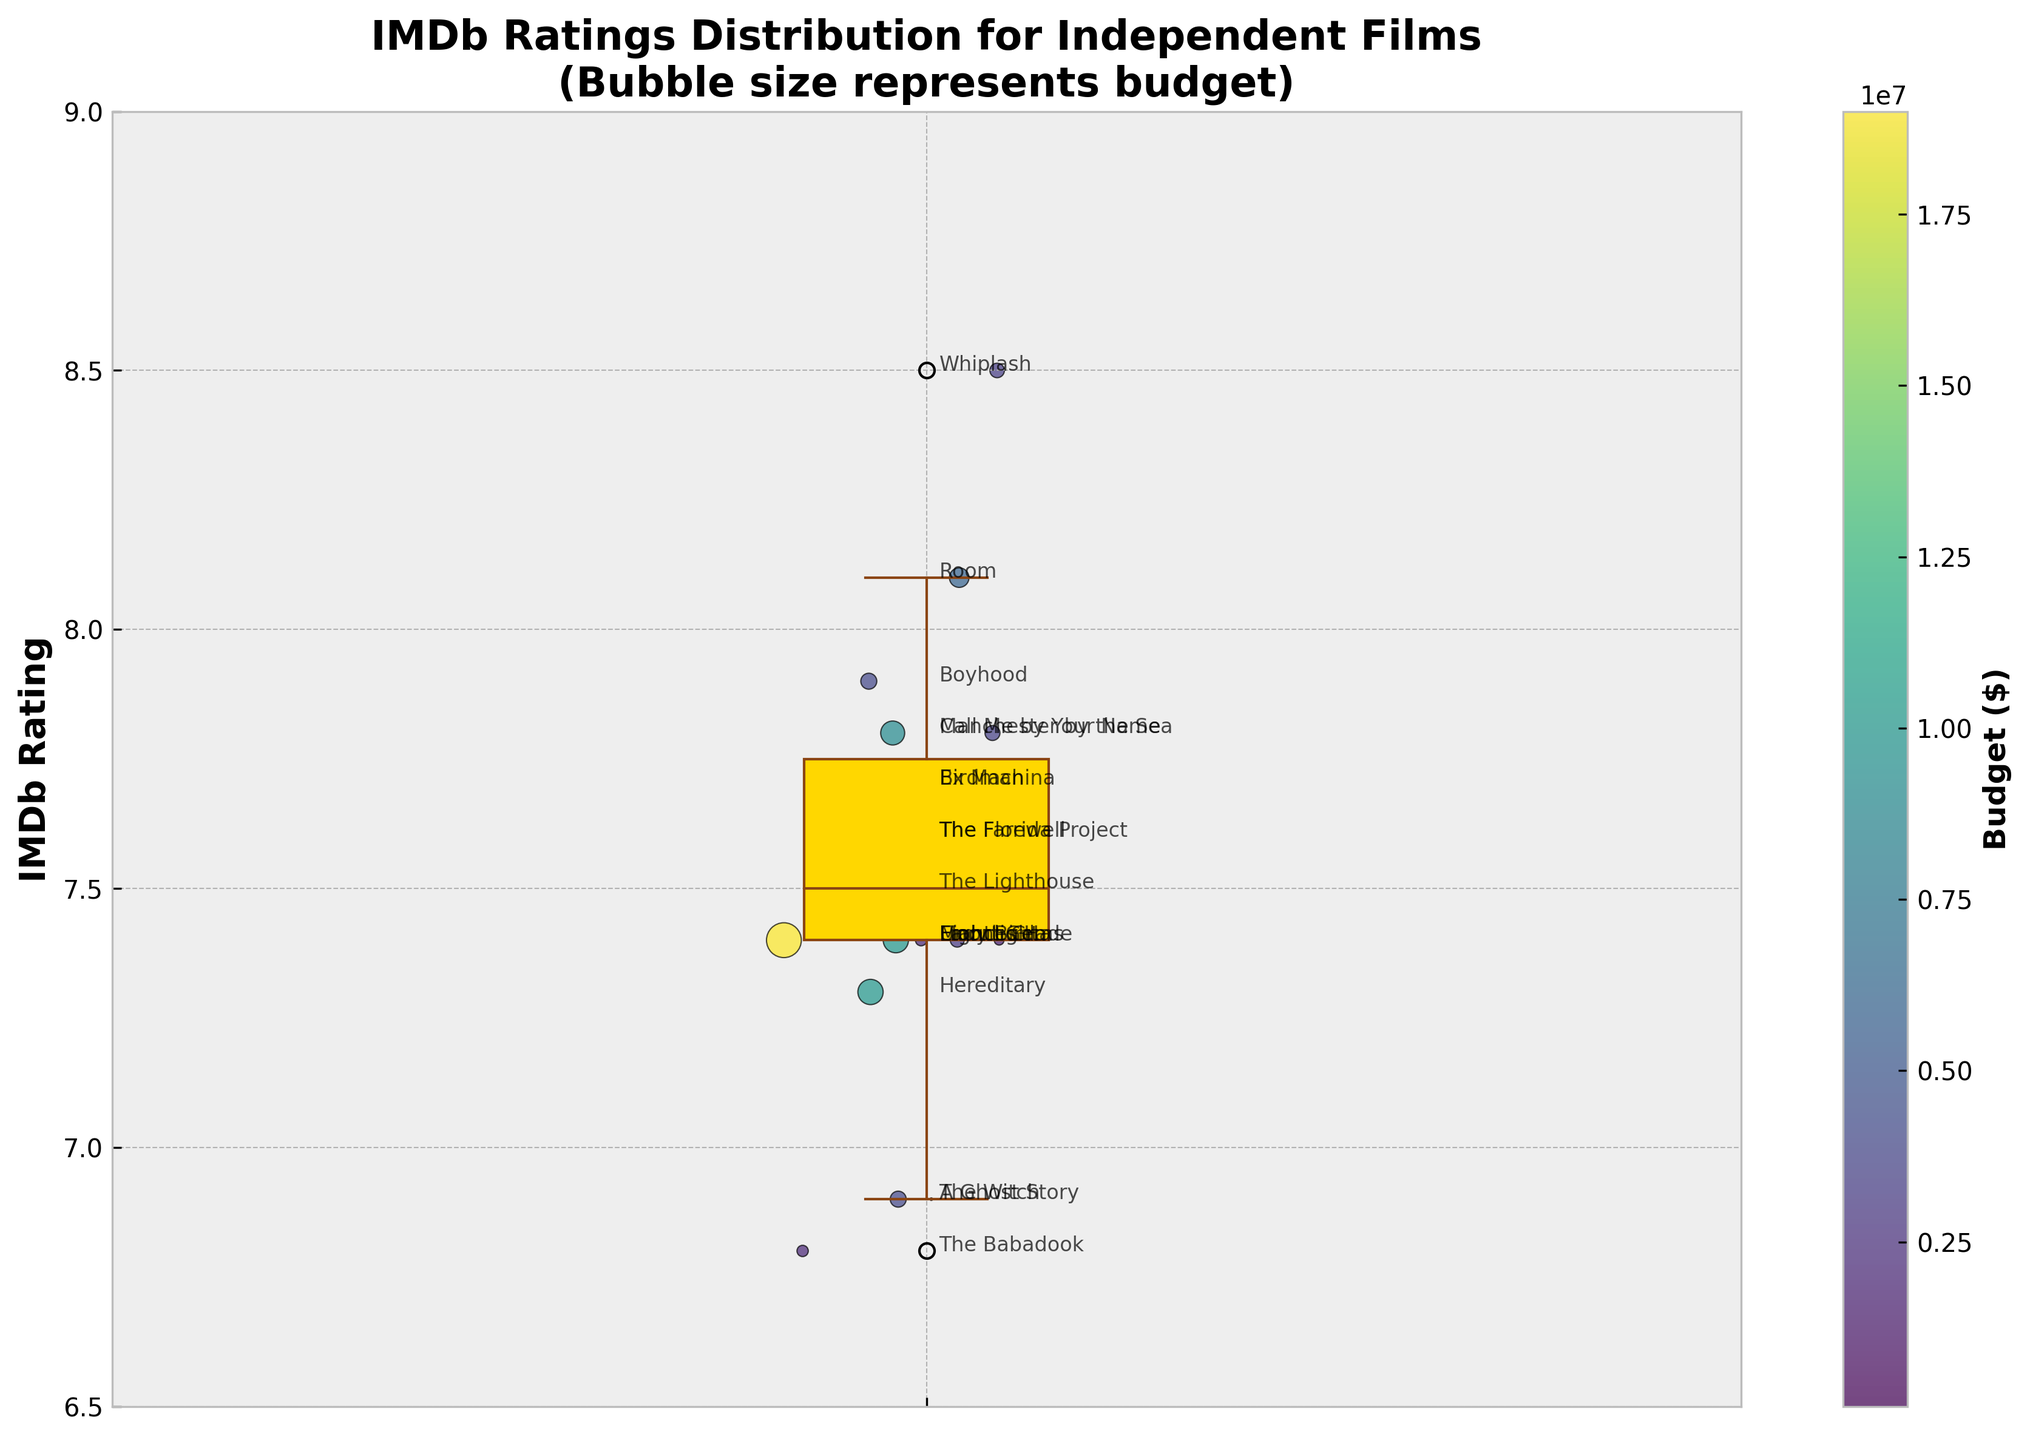Which movie has the highest IMDb rating? By examining the scatter points, the film with the highest position on the y-axis corresponds to the highest IMDb rating. This is "Whiplash" with an IMDb rating of 8.5.
Answer: Whiplash What is the main color scheme used in the scatter points? The color of the scatter points is based on the budget, and the color bar on the right indicates a viridis color scheme, which varies from blue to yellow as the budget increases.
Answer: Viridis (blue to yellow) What is the median IMDb rating for these independent films? The median IMDb rating is the middle value of the data points when ordered. It is highlighted by the horizontal line within the box in the box plot, and this value is approximately 7.4.
Answer: 7.4 Which film had the smallest budget and what was its IMDb rating? The smallest bubble represents the smallest budget. "A Ghost Story" has the smallest bubble, indicating a budget of $100,000, and its IMDb rating is 6.9.
Answer: A Ghost Story, 6.9 How does the budget size influence the scatter points' appearance? The size of the scatter points (bubbles) is scaled to represent the budget size—the larger the bubble, the higher the budget. This is visually confirmed by comparing the bubble sizes across the scatter plot.
Answer: Larger budgets have larger bubbles, smaller budgets have smaller bubbles Are there any films with exactly the same IMDb rating but different budgets? By checking the scatter points at the same y-level (IMDb rating), films "Moonlight," "Lady Bird," "Eighth Grade," "Uncut Gems," and "Frances Ha" all have an IMDb rating of 7.4 but different budget sizes, which is evident from the varied bubble sizes.
Answer: Yes (e.g., Moonlight and Lady Bird) Which film has the second-highest IMDb rating and how does its budget compare to the highest-rated film? The second-highest IMDb rating point corresponds to "Room" with an IMDb rating of 8.1. Comparing its bubble size (budget of $6,000,000) to "Whiplash" (budget of $3,300,000), "Room" has a higher budget.
Answer: Room, higher budget than Whiplash What is the range of the IMDb ratings for these films? The range is calculated by subtracting the minimum IMDb rating from the maximum IMDb rating. The lowest rating is 6.8 (The Babadook) and the highest rating is 8.5 (Whiplash). The range is 8.5 - 6.8 = 1.7.
Answer: 1.7 Which film's bubble size suggests it had the highest budget, and what is its IMDb rating? The largest bubble on the scatter plot indicates the highest budget, where "Birdman" has the largest bubble, suggesting a budget of $18,000,000. Its IMDb rating is 7.7.
Answer: Birdman, 7.7 